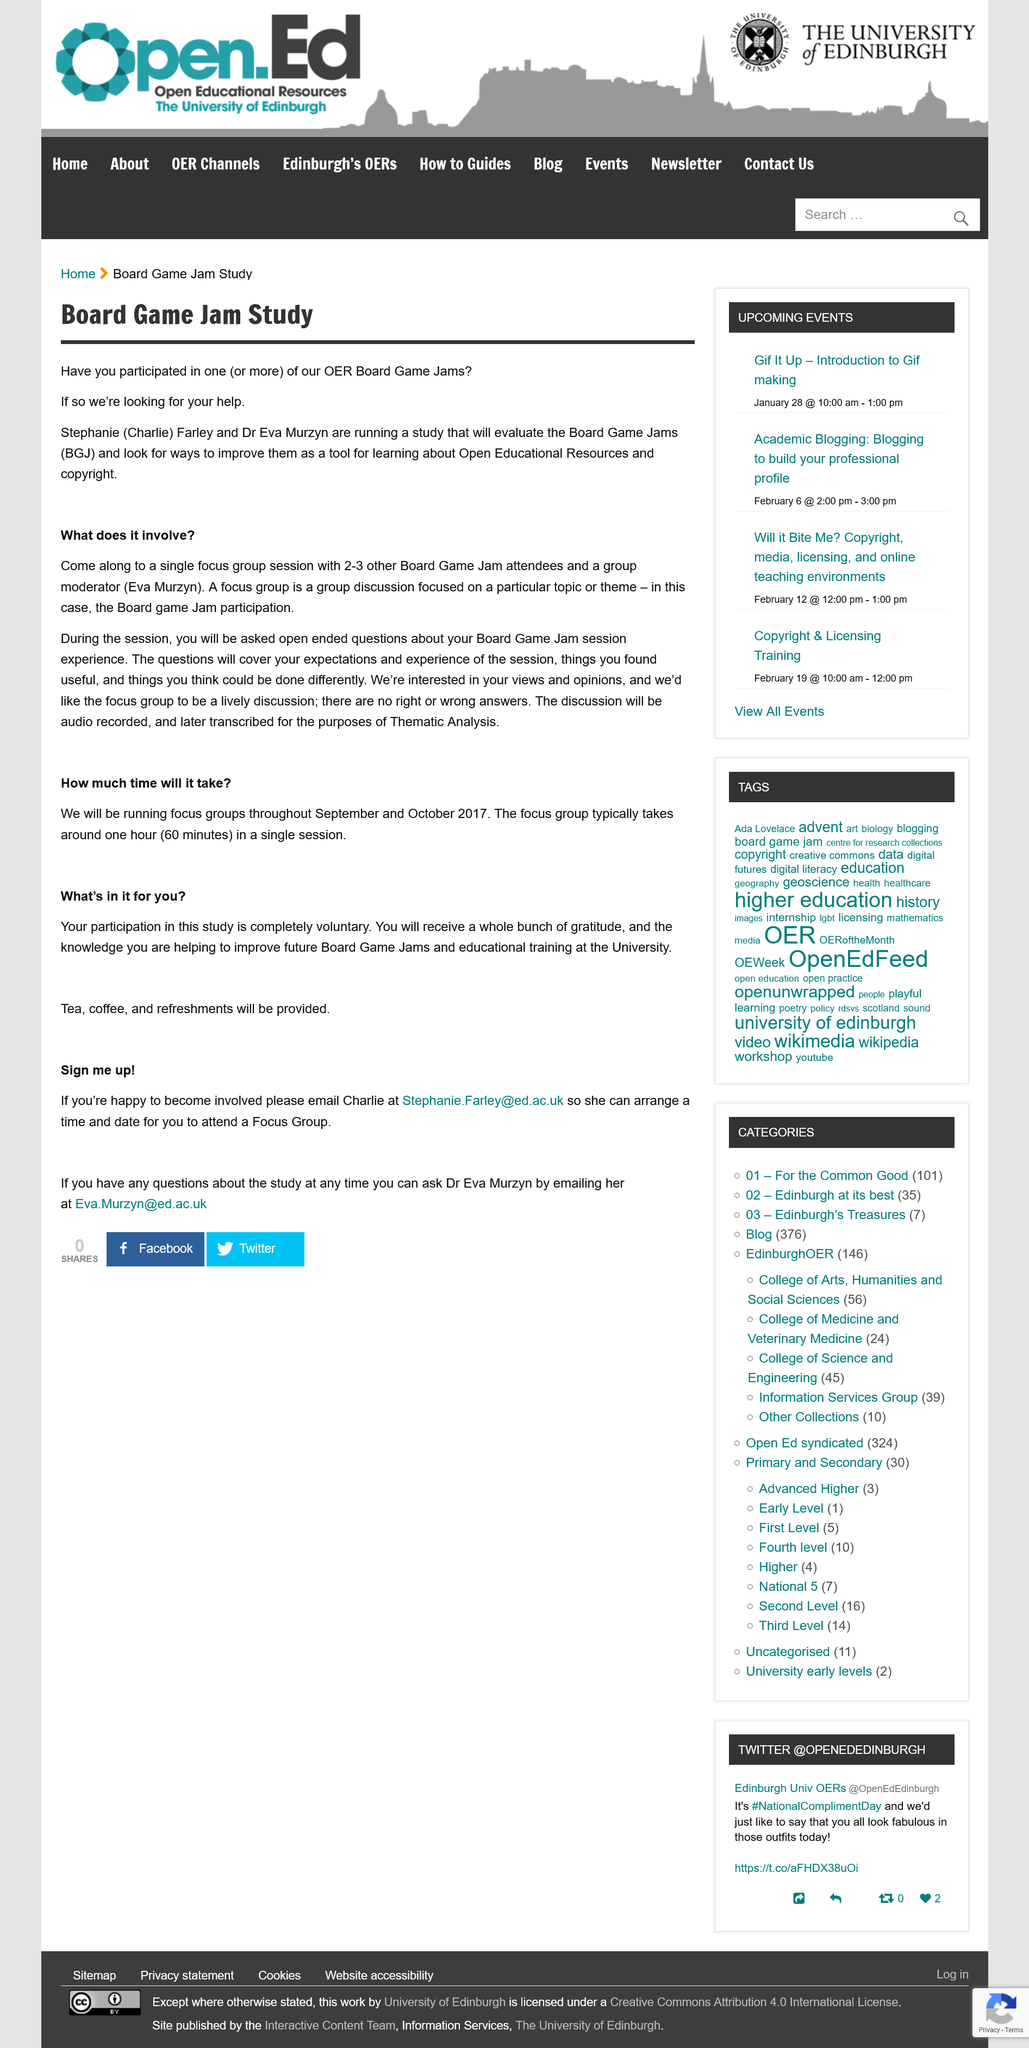Indicate a few pertinent items in this graphic. The duration of a typical focus group session is approximately 60 minutes. The discussion will be recorded in audio form and later transcribed. Participation is voluntary and not involuntary, as it is the individual's choice to participate or not. Therefore, it is a voluntary act. If you participate, tea, coffee, and refreshments will be provided. The group moderator for this focus group session is Eva Murzyn. 